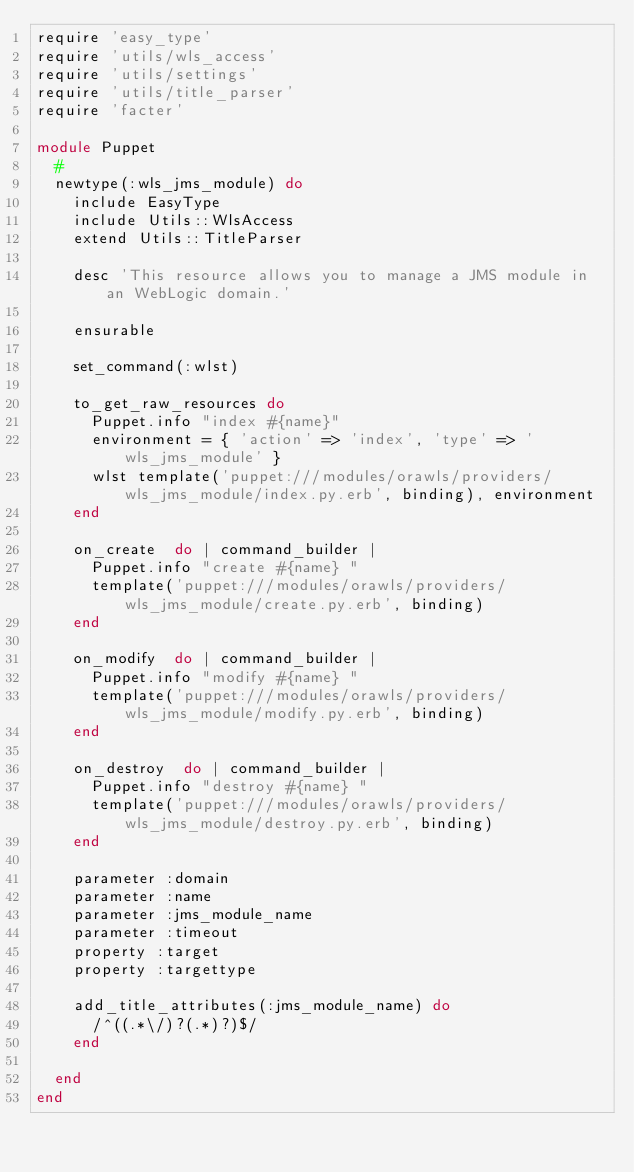Convert code to text. <code><loc_0><loc_0><loc_500><loc_500><_Ruby_>require 'easy_type'
require 'utils/wls_access'
require 'utils/settings'
require 'utils/title_parser'
require 'facter'

module Puppet
  #
  newtype(:wls_jms_module) do
    include EasyType
    include Utils::WlsAccess
    extend Utils::TitleParser

    desc 'This resource allows you to manage a JMS module in an WebLogic domain.'

    ensurable

    set_command(:wlst)

    to_get_raw_resources do
      Puppet.info "index #{name}"
      environment = { 'action' => 'index', 'type' => 'wls_jms_module' }
      wlst template('puppet:///modules/orawls/providers/wls_jms_module/index.py.erb', binding), environment
    end

    on_create  do | command_builder |
      Puppet.info "create #{name} "
      template('puppet:///modules/orawls/providers/wls_jms_module/create.py.erb', binding)
    end

    on_modify  do | command_builder |
      Puppet.info "modify #{name} "
      template('puppet:///modules/orawls/providers/wls_jms_module/modify.py.erb', binding)
    end

    on_destroy  do | command_builder |
      Puppet.info "destroy #{name} "
      template('puppet:///modules/orawls/providers/wls_jms_module/destroy.py.erb', binding)
    end

    parameter :domain
    parameter :name
    parameter :jms_module_name
    parameter :timeout
    property :target
    property :targettype

    add_title_attributes(:jms_module_name) do
      /^((.*\/)?(.*)?)$/
    end

  end
end
</code> 